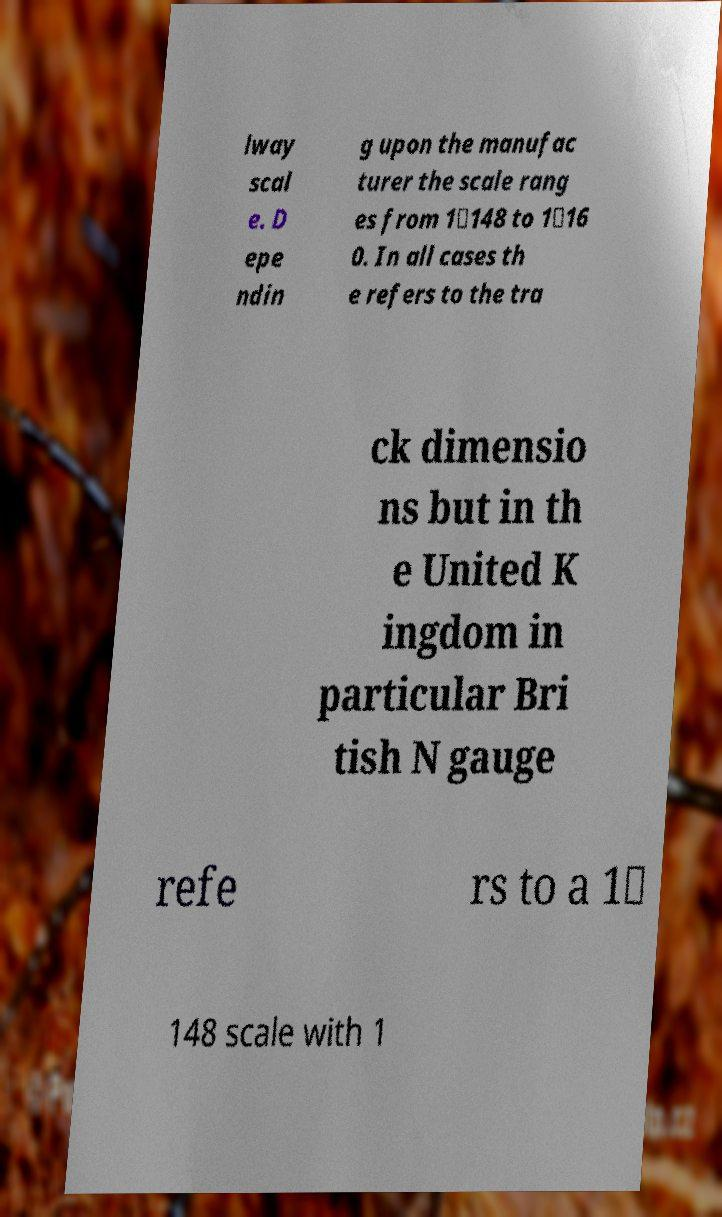Please read and relay the text visible in this image. What does it say? lway scal e. D epe ndin g upon the manufac turer the scale rang es from 1∶148 to 1∶16 0. In all cases th e refers to the tra ck dimensio ns but in th e United K ingdom in particular Bri tish N gauge refe rs to a 1∶ 148 scale with 1 